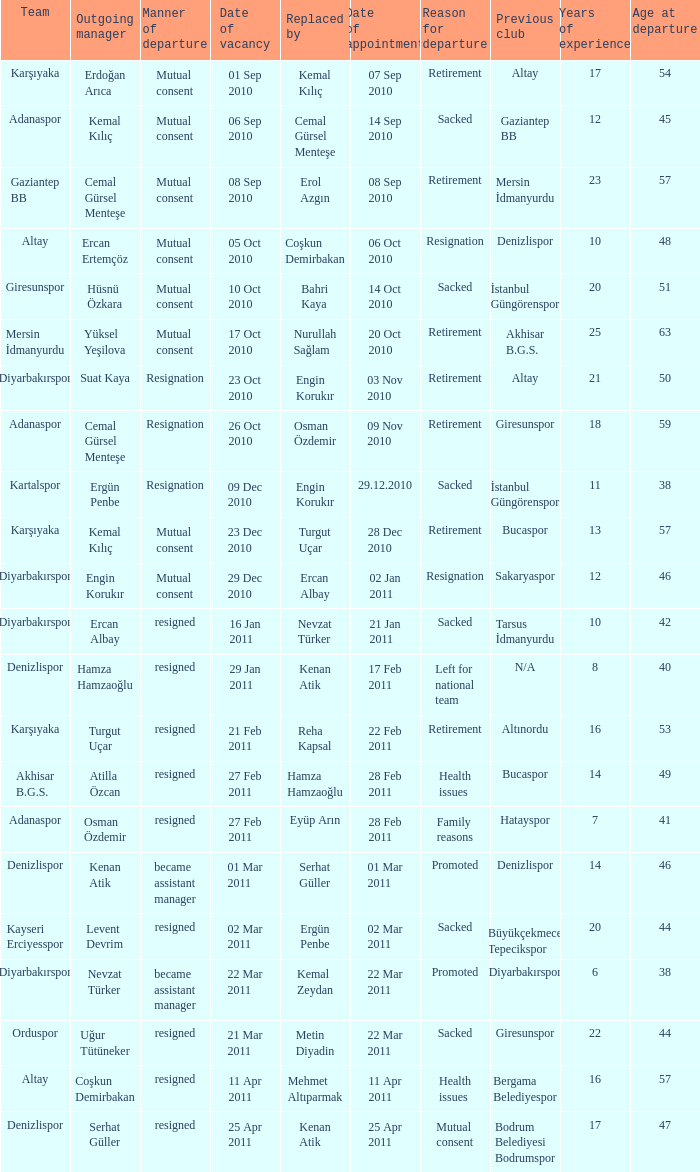Which team replaced their manager with Serhat Güller? Denizlispor. 